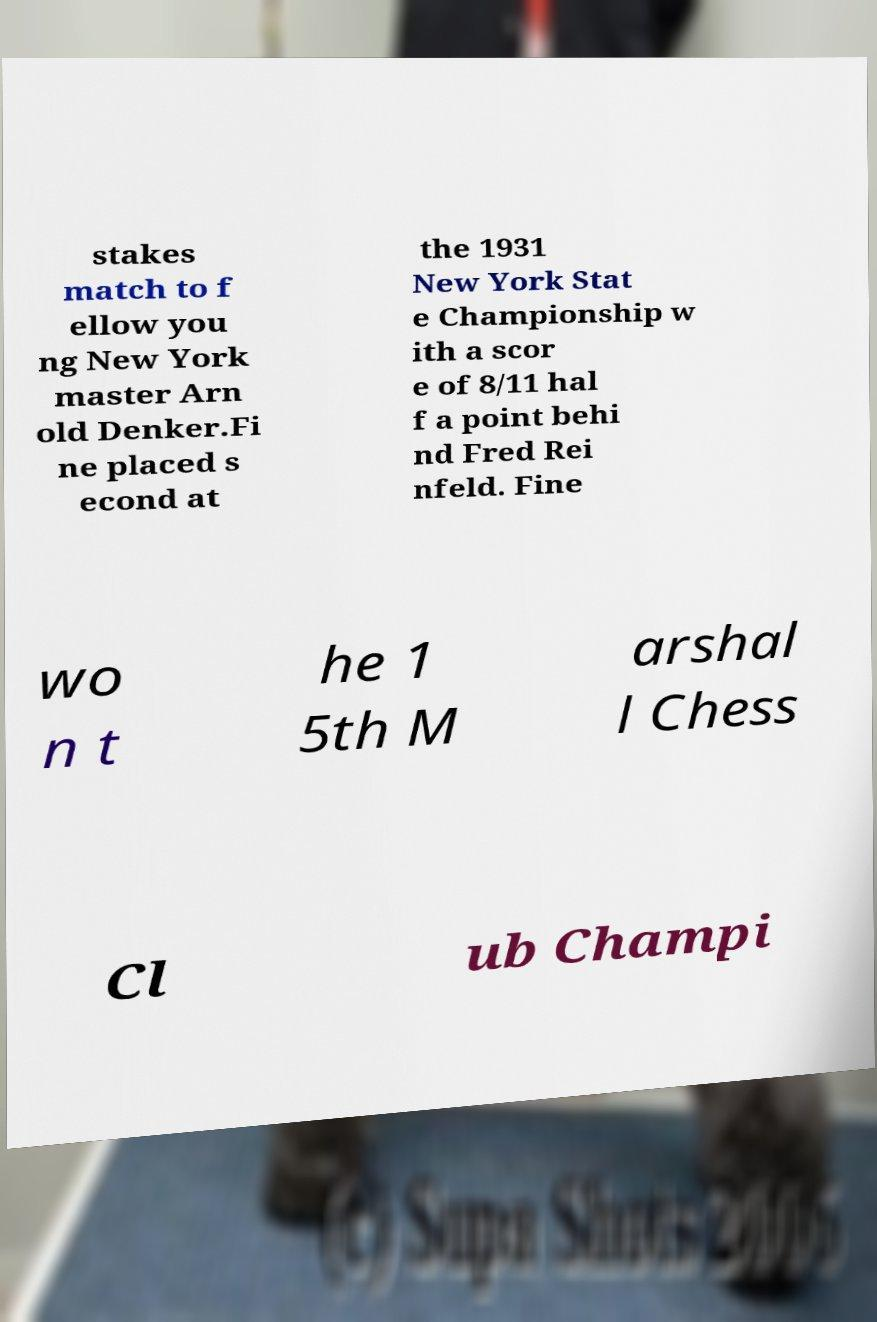What messages or text are displayed in this image? I need them in a readable, typed format. stakes match to f ellow you ng New York master Arn old Denker.Fi ne placed s econd at the 1931 New York Stat e Championship w ith a scor e of 8/11 hal f a point behi nd Fred Rei nfeld. Fine wo n t he 1 5th M arshal l Chess Cl ub Champi 